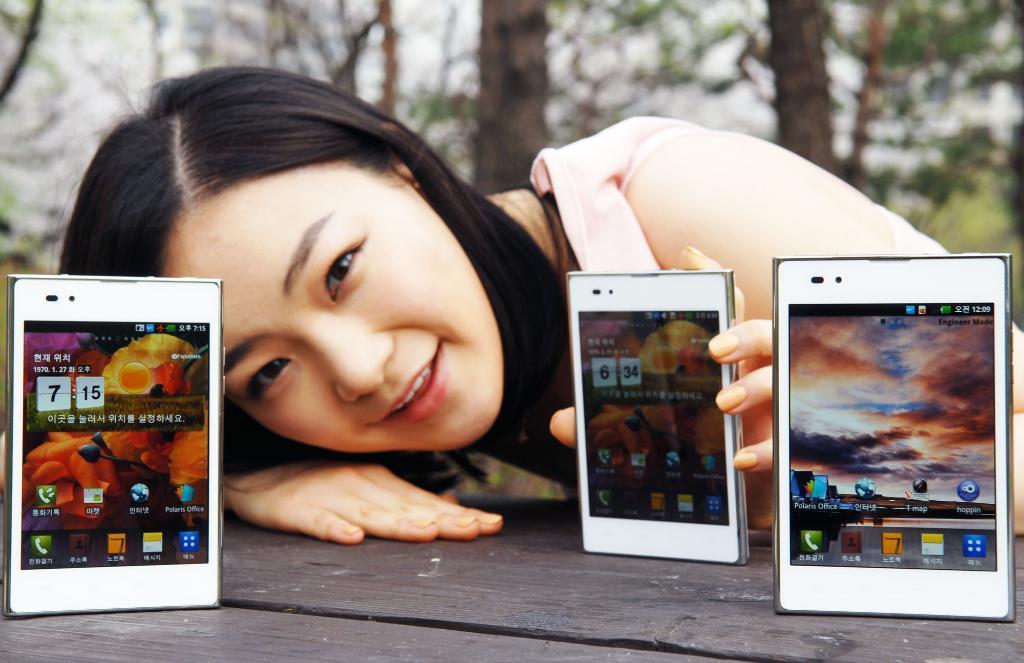Could you give a brief overview of what you see in this image? A woman is holding a mobile. There are three mobiles on the table. In the background there are some trees. 